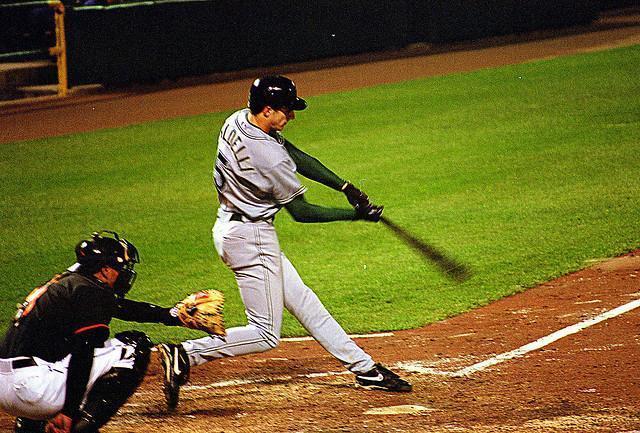How many people are there?
Give a very brief answer. 2. How many baseball gloves are there?
Give a very brief answer. 1. 